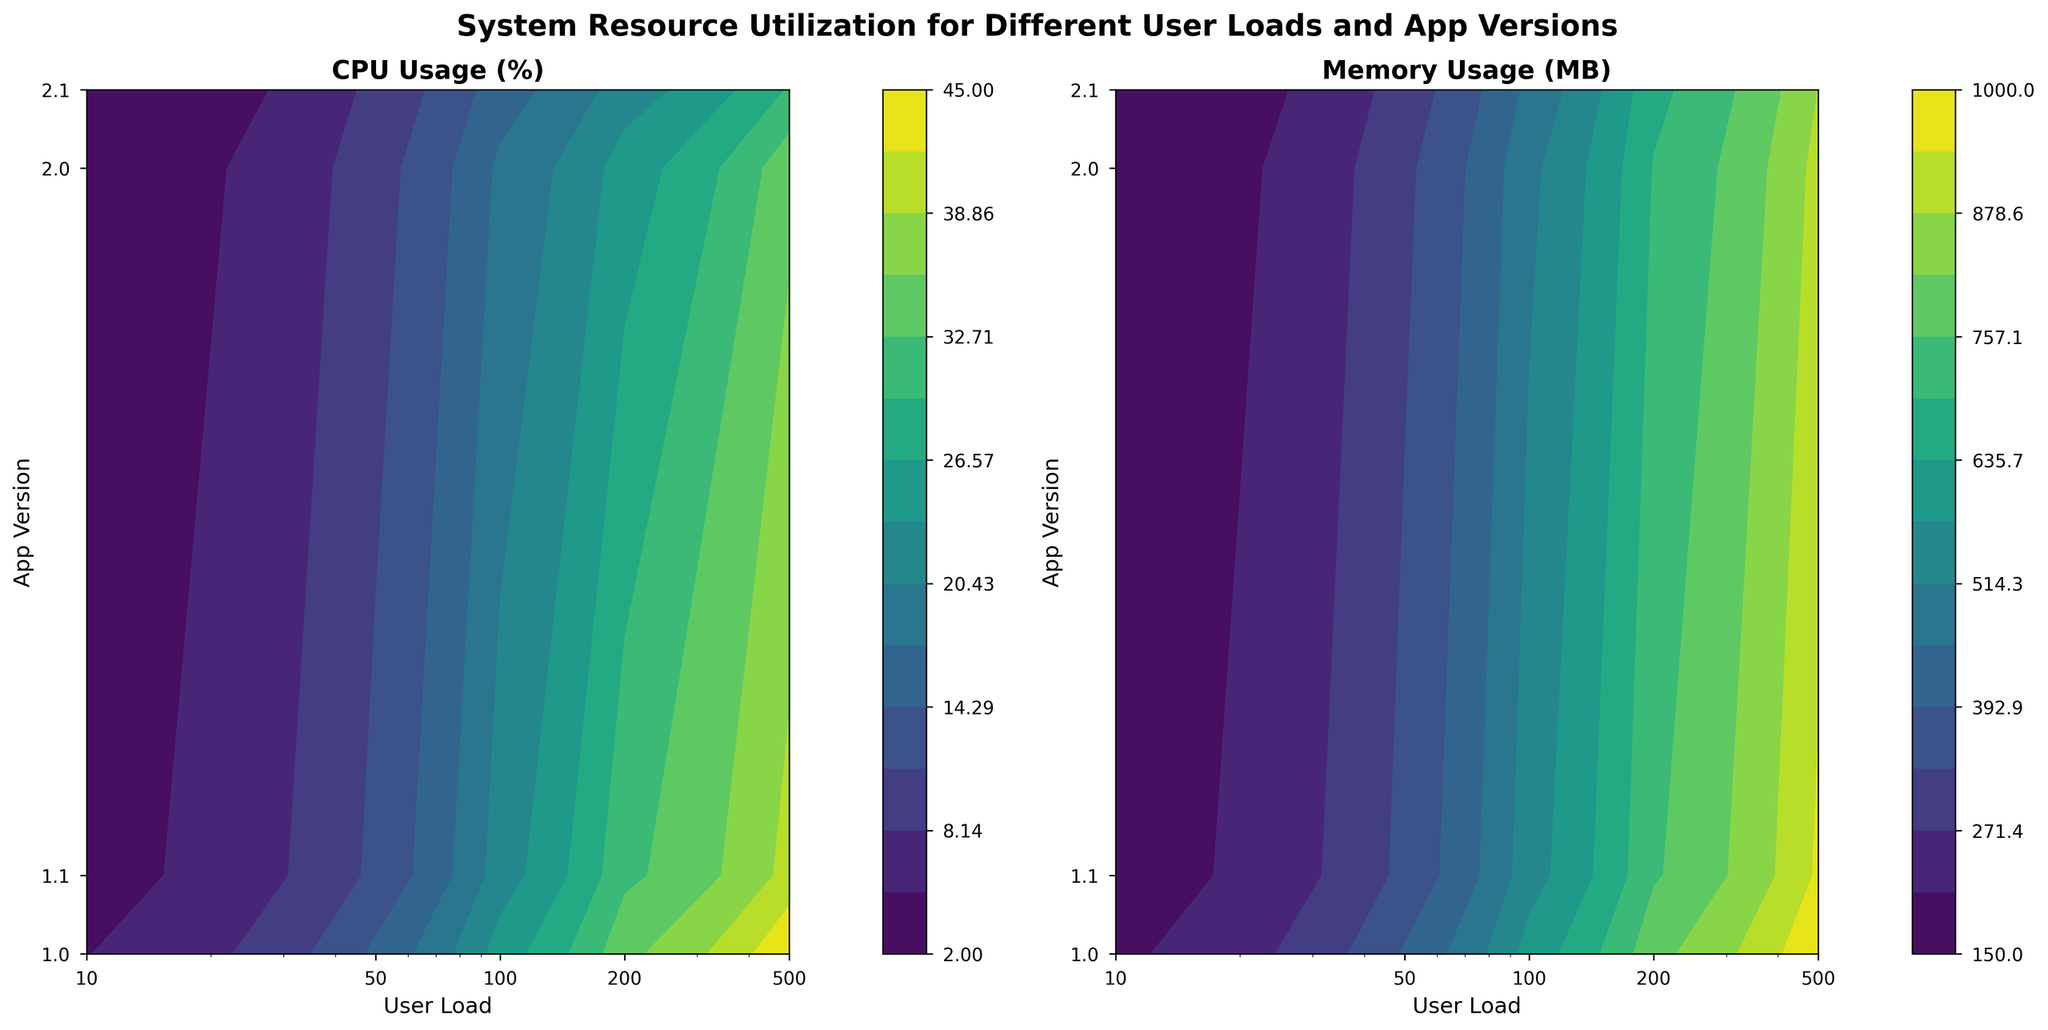What is noted in the title of the figure? The title is prominently displayed at the top of the figure. It reads "System Resource Utilization for Different User Loads and App Versions," indicating what the visualizations are about.
Answer: System Resource Utilization for Different User Loads and App Versions What do the X and Y axes represent? The X-axis represents 'User Load', while the Y-axis represents 'App Version.' This means we are looking at how system resource utilization varies across different user loads and app versions.
Answer: User Load, App Version What color scheme is used in the contour plots? The contour plots use a color scheme that ranges from dark to light colors. The colormap employed is 'viridis,' which generally moves from dark blue/purple through green to yellow.
Answer: viridis Which app version shows the lowest CPU usage at 500 user load? In the 'CPU Usage (%)' plot, the app version 2.1 shows the lowest contour value for 500 user load, indicating the lowest CPU usage.
Answer: 2.1 How does memory usage change from app version 1.0 to app version 2.1 for a user load of 100? By comparing the contours in the 'Memory Usage (MB)' plot for a user load of 100, we can see that the memory usage decreases progressively as the app version goes from 1.0 to 2.1.
Answer: It decreases Which app version shows the highest CPU usage and at what user load? In the 'CPU Usage (%)' plot, the app version 1.0 shows the highest CPU usage at 500 user load, represented by the darkest contour.
Answer: 1.0 at 500 user load What is the approximate CPU usage for app version 1.1 at a user load of 200? Referring to the 'CPU Usage (%)' plot, for app version 1.1 at a user load of 200, the CPU usage appears at the contour level of about 32%.
Answer: 32% By how much does memory usage differ between app versions 1.0 and 2.0 at a user load of 50? In the 'Memory Usage (MB)' plot, at a user load of 50, app version 1.0 has a memory usage of about 400 MB, and app version 2.0 has about 320 MB. The difference is 400 - 320 = 80 MB.
Answer: 80 MB Which app version shows the most consistent system resource usage (both CPU and memory) across different user loads? By observing both subplots, app version 2.1 shows the most consistent system resource usage with the least steep contour changes across different user loads for both CPU and memory usage.
Answer: 2.1 